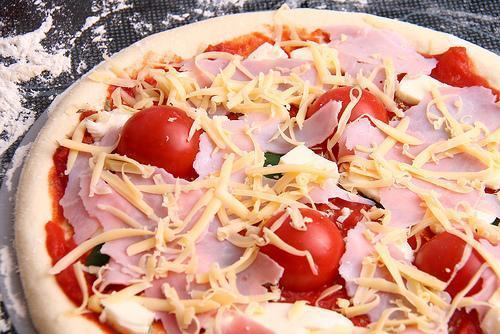How many pizzas are shown here?
Give a very brief answer. 1. How many people are in this picture?
Give a very brief answer. 0. How many tomatoes are shown on the pizza?
Give a very brief answer. 4. 